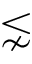<formula> <loc_0><loc_0><loc_500><loc_500>\lnsim</formula> 